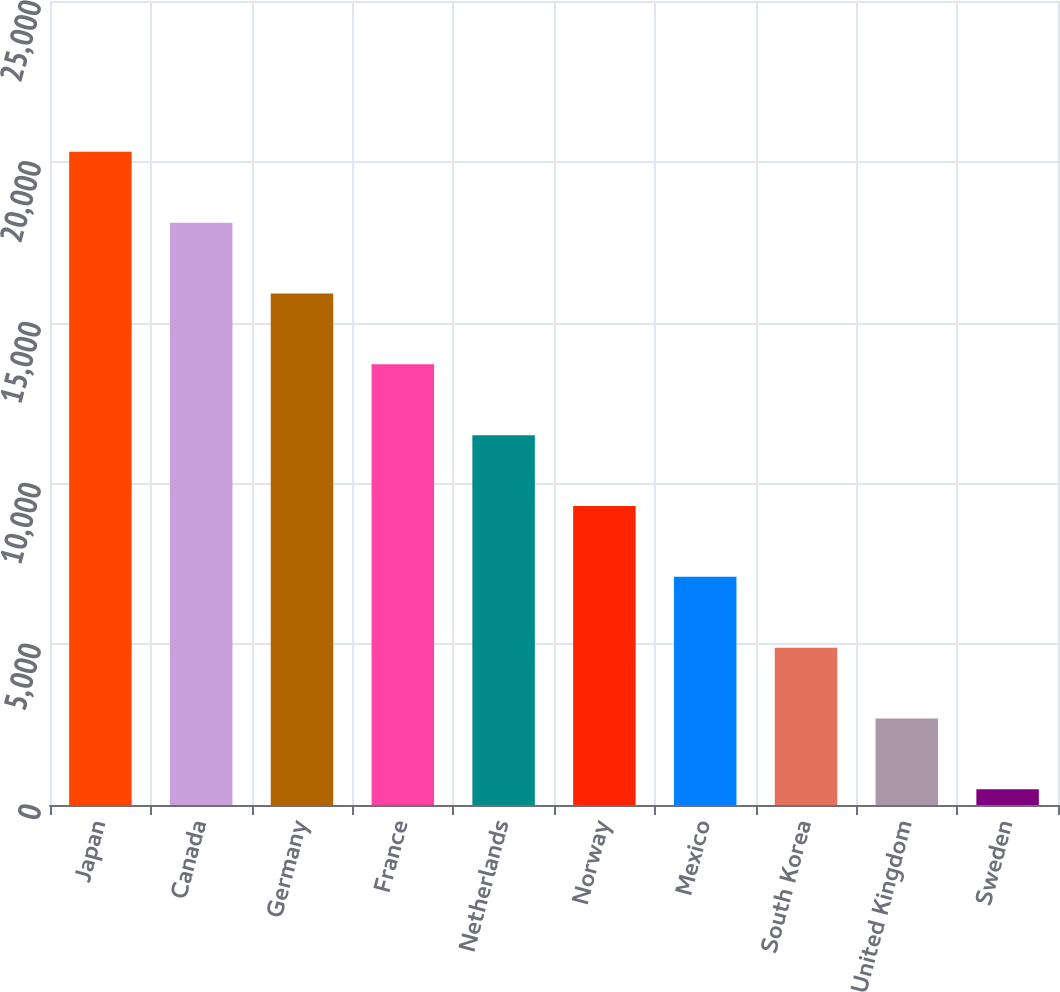Convert chart. <chart><loc_0><loc_0><loc_500><loc_500><bar_chart><fcel>Japan<fcel>Canada<fcel>Germany<fcel>France<fcel>Netherlands<fcel>Norway<fcel>Mexico<fcel>South Korea<fcel>United Kingdom<fcel>Sweden<nl><fcel>20308.7<fcel>18106.4<fcel>15904.1<fcel>13701.8<fcel>11499.5<fcel>9297.2<fcel>7094.9<fcel>4892.6<fcel>2690.3<fcel>488<nl></chart> 